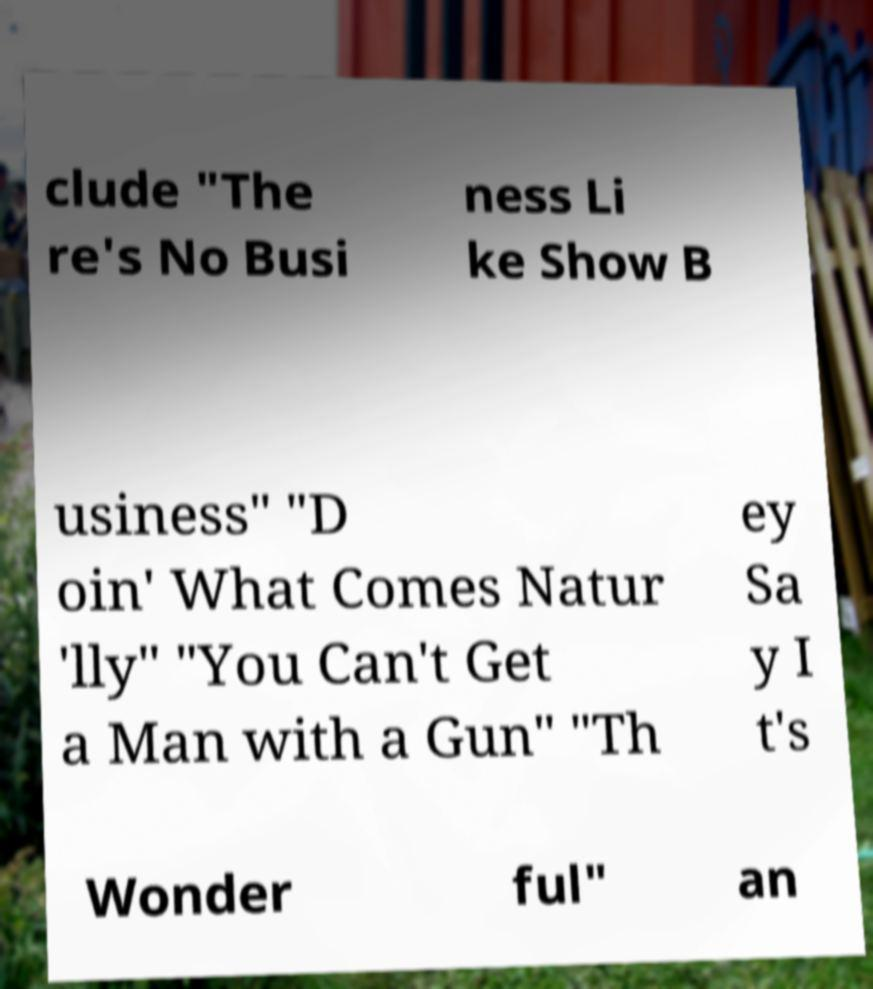What messages or text are displayed in this image? I need them in a readable, typed format. clude "The re's No Busi ness Li ke Show B usiness" "D oin' What Comes Natur 'lly" "You Can't Get a Man with a Gun" "Th ey Sa y I t's Wonder ful" an 